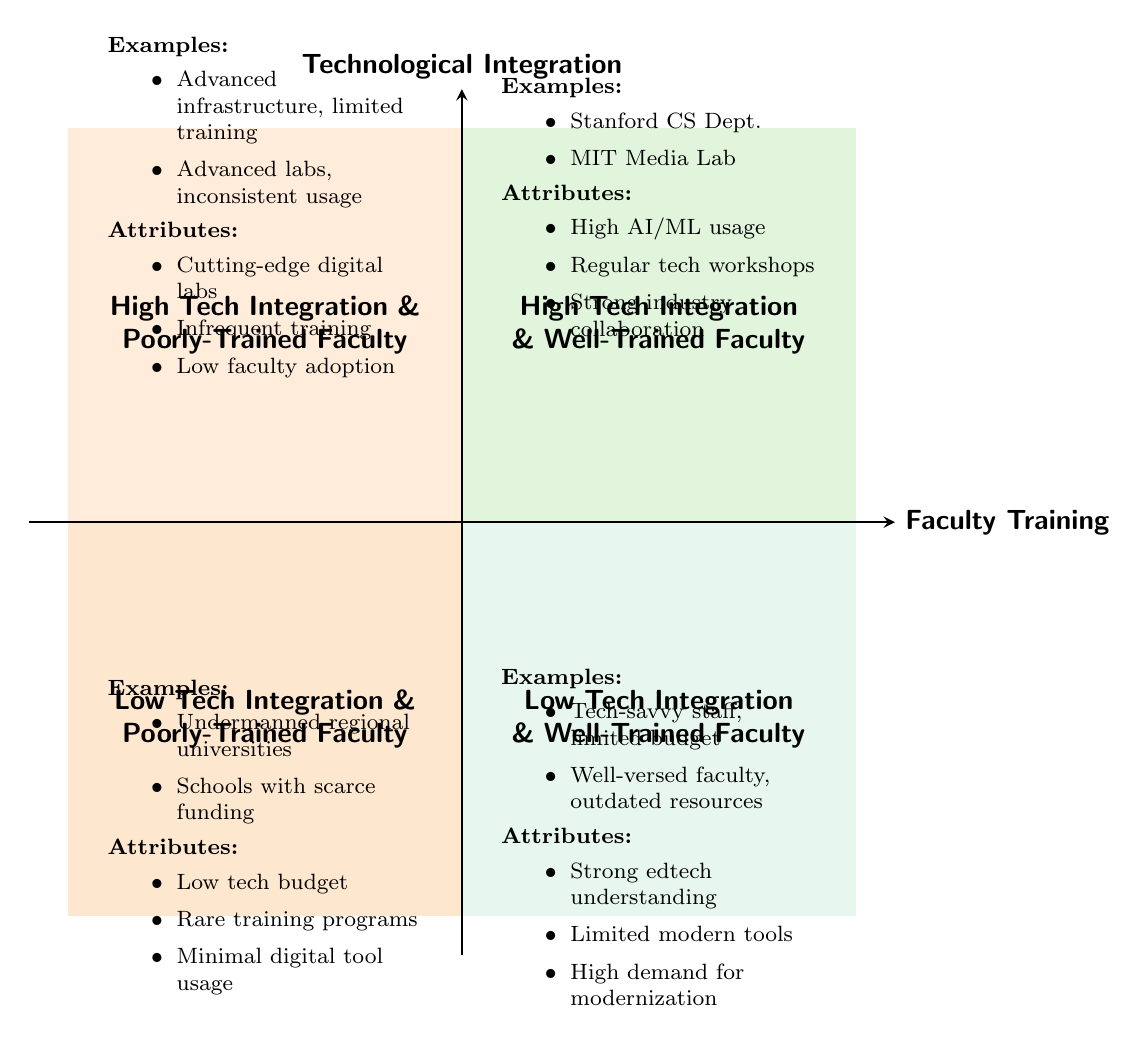What are the names of the quadrants representing high technological integration with well-trained faculty? The quadrant diagram indicates the names of the quadrants clearly. The quadrant in the top right corner is labeled as “High Tech Integration & Well-Trained Faculty.”
Answer: High Tech Integration & Well-Trained Faculty How many examples are listed under the quadrant for low technological integration and well-trained faculty? In the diagram, this quadrant is located in the bottom right section. It lists two examples: “A liberal arts college with a tech-savvy staff but limited budget” and “Community colleges with well-versed faculty but outdated tech resources.”
Answer: 2 What is one attribute of the quadrant with high technological integration and poorly-trained faculty? Looking at this quadrant in the upper left area of the diagram, it mentions one of the attributes as “Cutting-edge digital labs.”
Answer: Cutting-edge digital labs What is the relationship between technological integration and faculty training in the quadrant with low integration and poorly-trained faculty? This quadrant, located in the bottom left, features attributes that suggest a direct relationship of low technological integration with poorly-trained faculty. Both aspects are highlighted with attributes such as “Low budget for technological advancements” and “Rare or non-existent tech training programs for faculty.” Thus, indicating a cohesive connection of both being low.
Answer: Both are low Which quadrant has attributes indicating high investment in technology tools? The quadrant that discusses high investment in technology tools is found in the upper left, known as “High Tech Integration & Poorly-Trained Faculty.” Here, it mentions “High investment in technology tools, but low adoption by faculty.”
Answer: High Tech Integration & Poorly-Trained Faculty What does the presence of “strong demand for modernization from faculty” suggest about the quadrant with low technological integration and well-trained faculty? The presence of this attribute in the quadrant reflecting low technological integration with well-trained faculty indicates that, despite the low availability of tech tools, faculty members possess a comprehension of technology and wish to enhance current capabilities, reflecting a proactive attitude towards improvement.
Answer: Suggests a proactive attitude towards improvement How do the examples listed in the quadrant for high technological integration and well-trained faculty compare to those in low integration with poorly-trained faculty? In the high integration quadrant, the examples showcase prestigious institutions like Stanford University and MIT, indicating successful technological use and faculty training. In contrast, the low integration quadrant presents undermanned regional universities with minimal tech investments, illustrating a stark contrast in resource availability and institutional support.
Answer: A stark contrast in resources and support What axis represents faculty training in the quadrant chart? The horizontal or x-axis of the diagram is clearly defined to represent 'Faculty Training,' distinguishing it from the vertical axis.
Answer: Faculty Training 